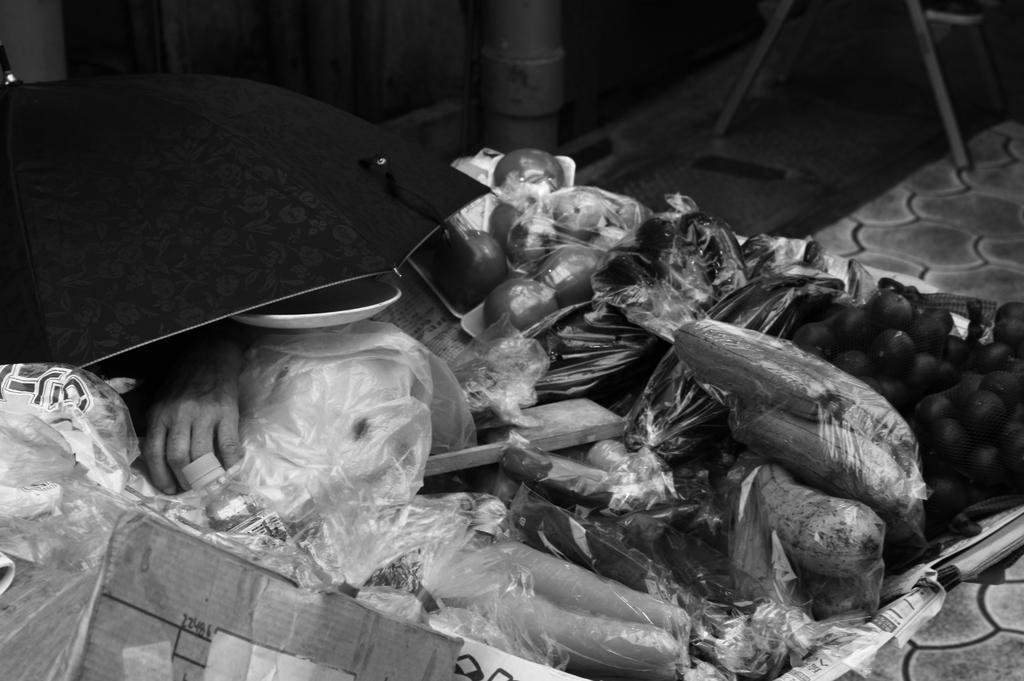Describe this image in one or two sentences. It looks like a black and white picture. We can see there is an umbrella, cardboard sheet, vegetables and some vegetables are wrapped in the covers. Behind the umbrella, it looks like a pipe and a chair. 